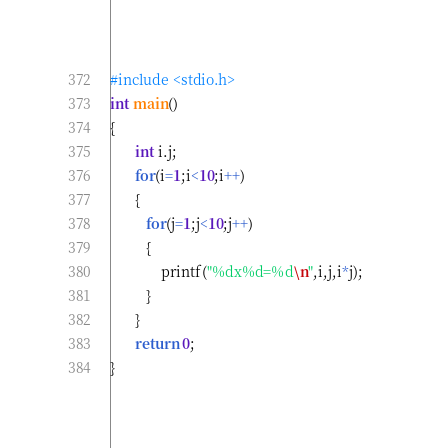<code> <loc_0><loc_0><loc_500><loc_500><_C_>#include <stdio.h>
int main()
{
       int i.j;
       for(i=1;i<10;i++)
       {
          for(j=1;j<10;j++)
          {
              printf("%dx%d=%d\n",i,j,i*j);
          }
       }
       return 0;
}
</code> 